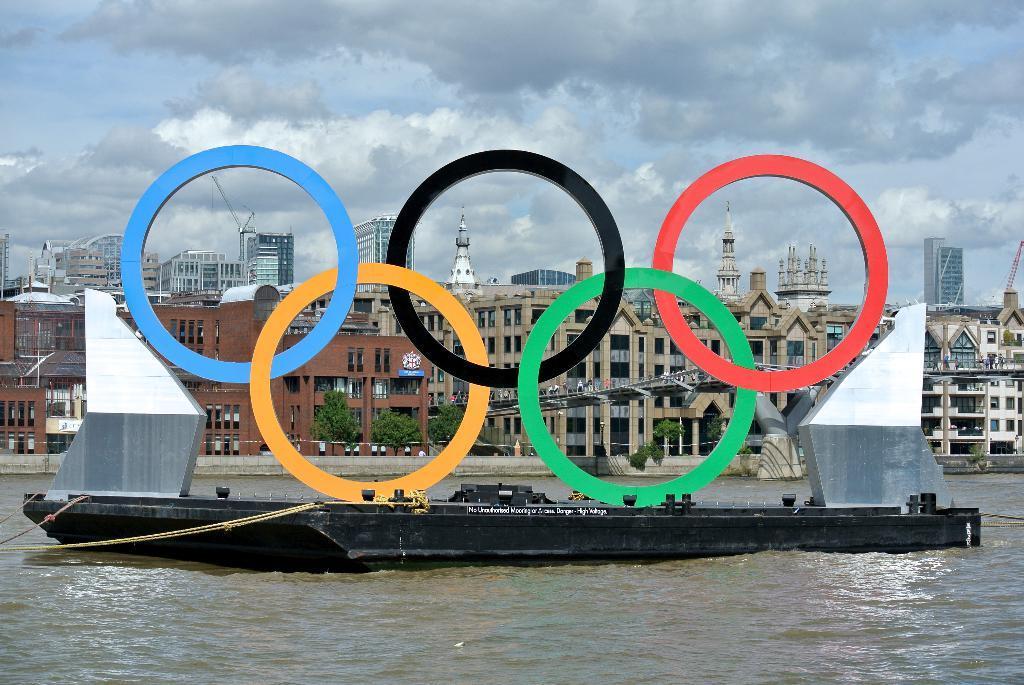Could you give a brief overview of what you see in this image? This image consists of a boat in black color. At the bottom, there is water. In the background, there are many buildings. At the top, there are clouds in the sky. 